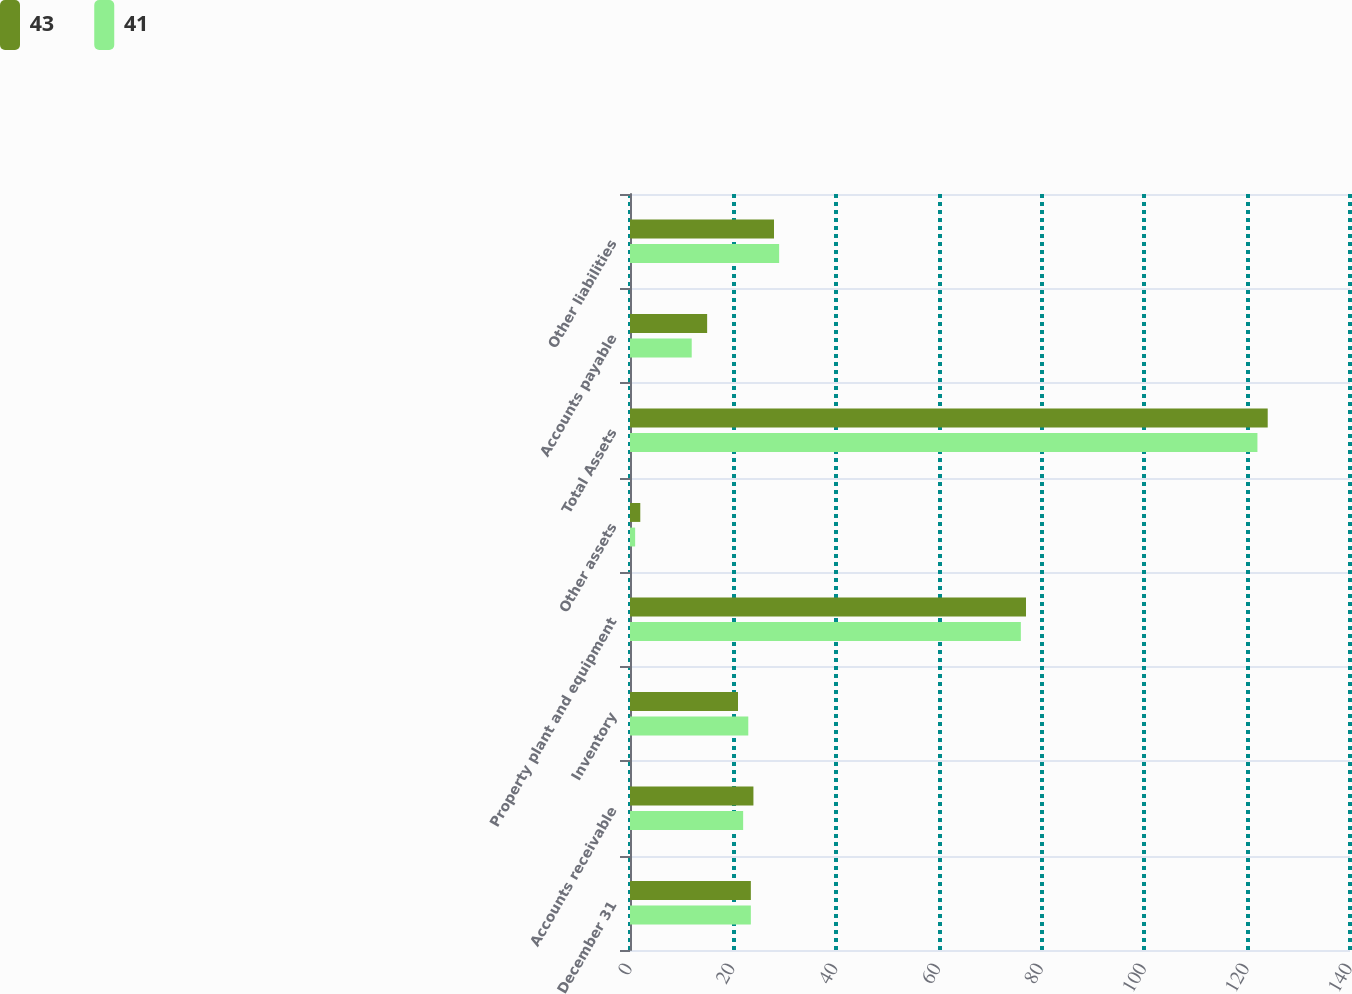<chart> <loc_0><loc_0><loc_500><loc_500><stacked_bar_chart><ecel><fcel>December 31<fcel>Accounts receivable<fcel>Inventory<fcel>Property plant and equipment<fcel>Other assets<fcel>Total Assets<fcel>Accounts payable<fcel>Other liabilities<nl><fcel>43<fcel>23.5<fcel>24<fcel>21<fcel>77<fcel>2<fcel>124<fcel>15<fcel>28<nl><fcel>41<fcel>23.5<fcel>22<fcel>23<fcel>76<fcel>1<fcel>122<fcel>12<fcel>29<nl></chart> 